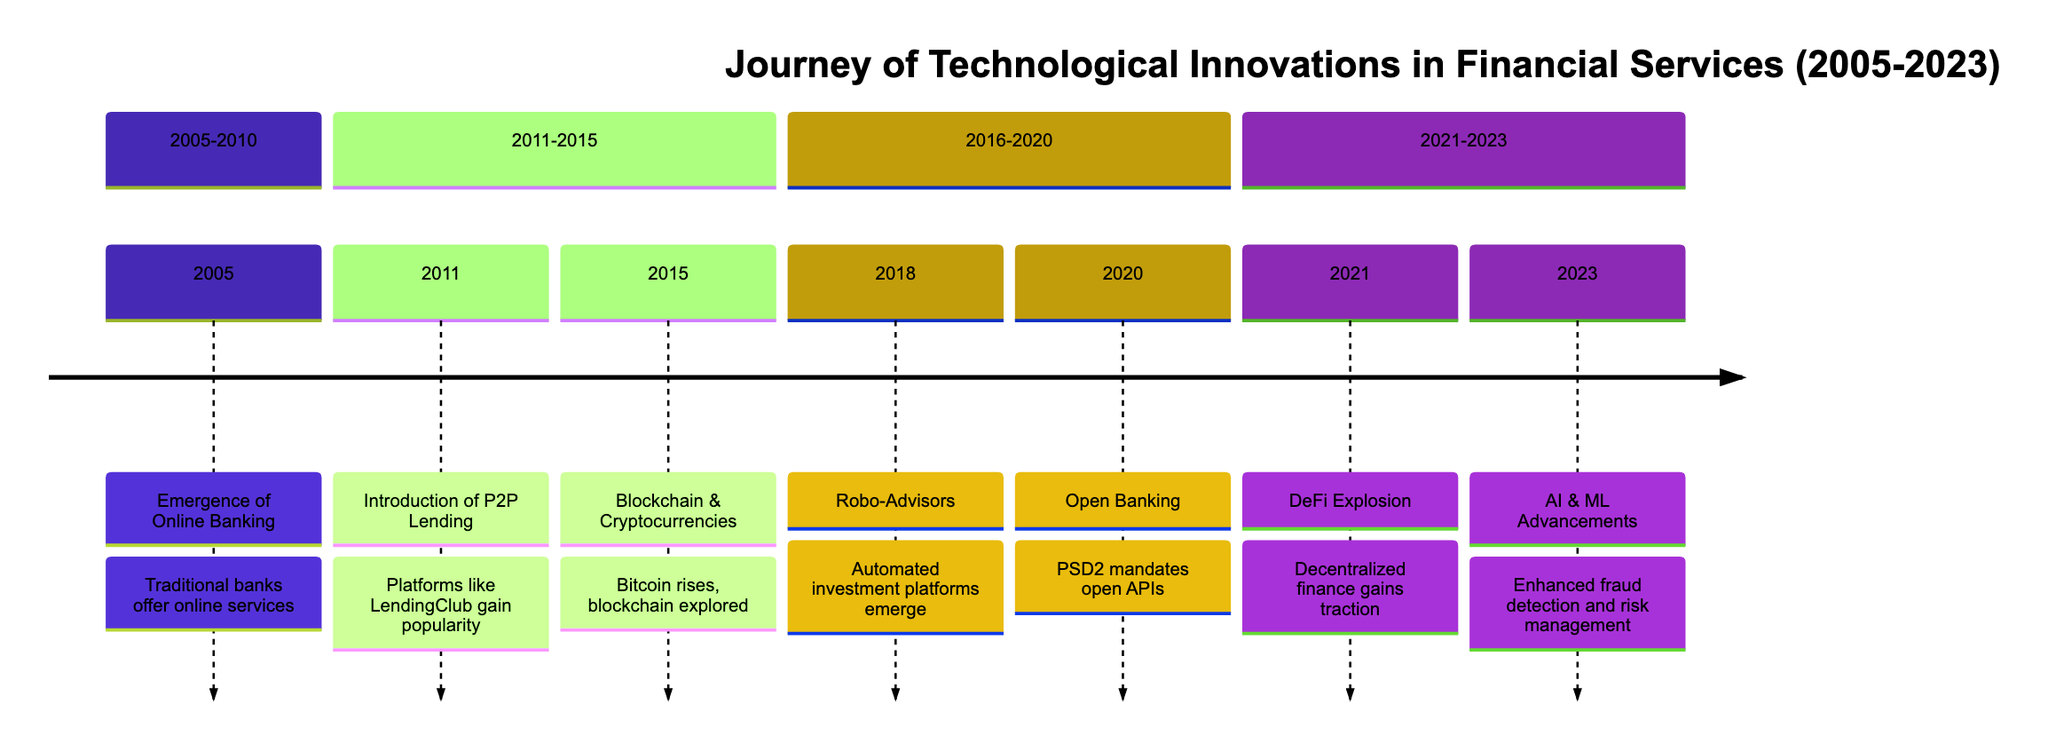What year did the emergence of online banking occur? According to the diagram, the emergence of online banking is marked in the year 2005.
Answer: 2005 What innovation was introduced in 2011? The timeline indicates that in 2011, the introduction of Peer-to-Peer (P2P) lending platforms occurred.
Answer: Peer-to-Peer (P2P) Lending Platforms How many innovations are listed in the timeline from 2005 to 2010? The timeline shows two innovations during this period: Emergence of Online Banking in 2005 and Growth of Mobile Banking in 2008. Therefore, count them to confirm there are two innovations.
Answer: 2 What is the main business model influence of robo-advisors mentioned in the timeline? The timeline describes the influence of robo-advisors on business models as providing cost-effective wealth management solutions and broadening access to investment advisory services.
Answer: Cost-effective wealth management solutions Which year saw the explosion of decentralized finance (DeFi)? The diagram notes that the explosion of decentralized finance (DeFi) occurred in the year 2021.
Answer: 2021 What investment opportunities arose from the advancements in AI and machine learning in finance? According to the timeline, investment opportunities from advancements in AI and machine learning include investment in AI and machine learning startups, data analytics platforms, and AI-driven financial services.
Answer: AI and machine learning startups What significant regulatory development occurred in 2020? The timeline states that in 2020, there was an adoption of Open Banking, mandated by regulatory frameworks like PSD2 in Europe.
Answer: Adoption of Open Banking What influence on business models does blockchain technology have? The influence of blockchain technology on business models includes the potential to revolutionize payment systems, increase transparency, and reduce fraud in financial transactions.
Answer: Revolutionize payment systems How does the introduction of P2P lending affect traditional lending processes? The timeline indicates that P2P lending disintermediates traditional lending processes, providing more competitive rates and democratizing access to capital, thus altering the nature of traditional lending.
Answer: Disintermediation of traditional lending processes 